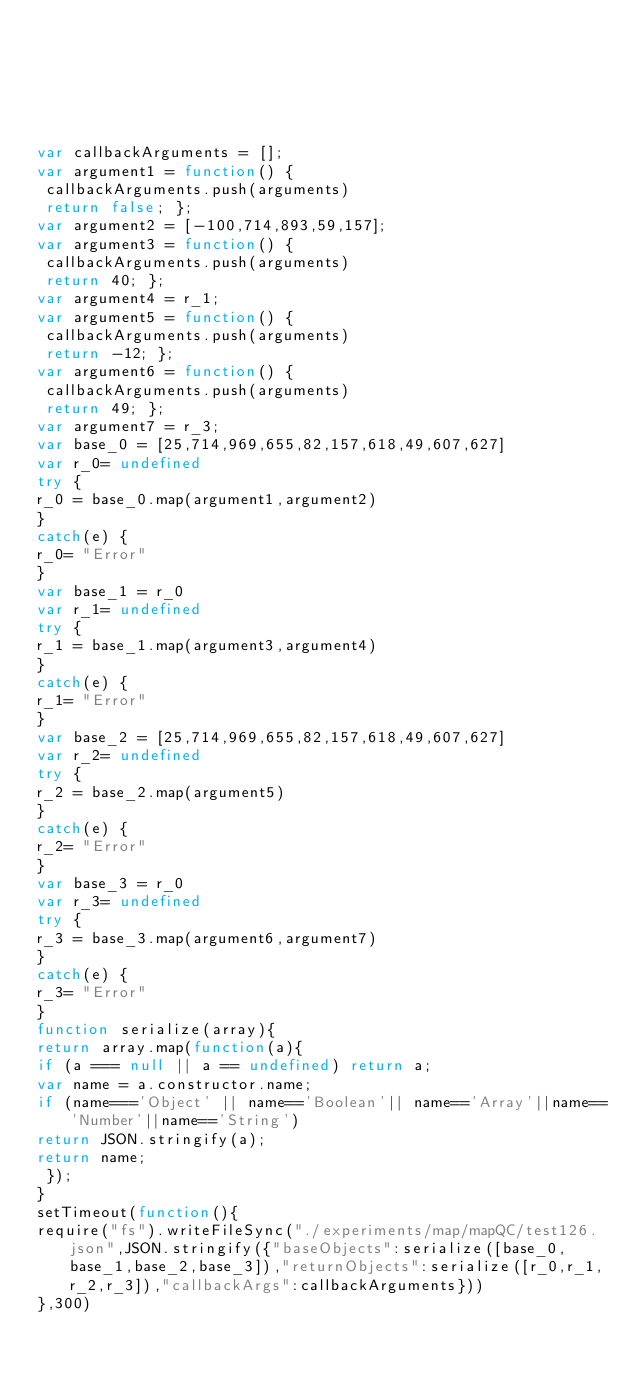<code> <loc_0><loc_0><loc_500><loc_500><_JavaScript_>





var callbackArguments = [];
var argument1 = function() {
 callbackArguments.push(arguments) 
 return false; };
var argument2 = [-100,714,893,59,157];
var argument3 = function() {
 callbackArguments.push(arguments) 
 return 40; };
var argument4 = r_1;
var argument5 = function() {
 callbackArguments.push(arguments) 
 return -12; };
var argument6 = function() {
 callbackArguments.push(arguments) 
 return 49; };
var argument7 = r_3;
var base_0 = [25,714,969,655,82,157,618,49,607,627]
var r_0= undefined
try {
r_0 = base_0.map(argument1,argument2)
}
catch(e) {
r_0= "Error"
}
var base_1 = r_0
var r_1= undefined
try {
r_1 = base_1.map(argument3,argument4)
}
catch(e) {
r_1= "Error"
}
var base_2 = [25,714,969,655,82,157,618,49,607,627]
var r_2= undefined
try {
r_2 = base_2.map(argument5)
}
catch(e) {
r_2= "Error"
}
var base_3 = r_0
var r_3= undefined
try {
r_3 = base_3.map(argument6,argument7)
}
catch(e) {
r_3= "Error"
}
function serialize(array){
return array.map(function(a){
if (a === null || a == undefined) return a;
var name = a.constructor.name;
if (name==='Object' || name=='Boolean'|| name=='Array'||name=='Number'||name=='String')
return JSON.stringify(a);
return name;
 });
}
setTimeout(function(){
require("fs").writeFileSync("./experiments/map/mapQC/test126.json",JSON.stringify({"baseObjects":serialize([base_0,base_1,base_2,base_3]),"returnObjects":serialize([r_0,r_1,r_2,r_3]),"callbackArgs":callbackArguments}))
},300)</code> 